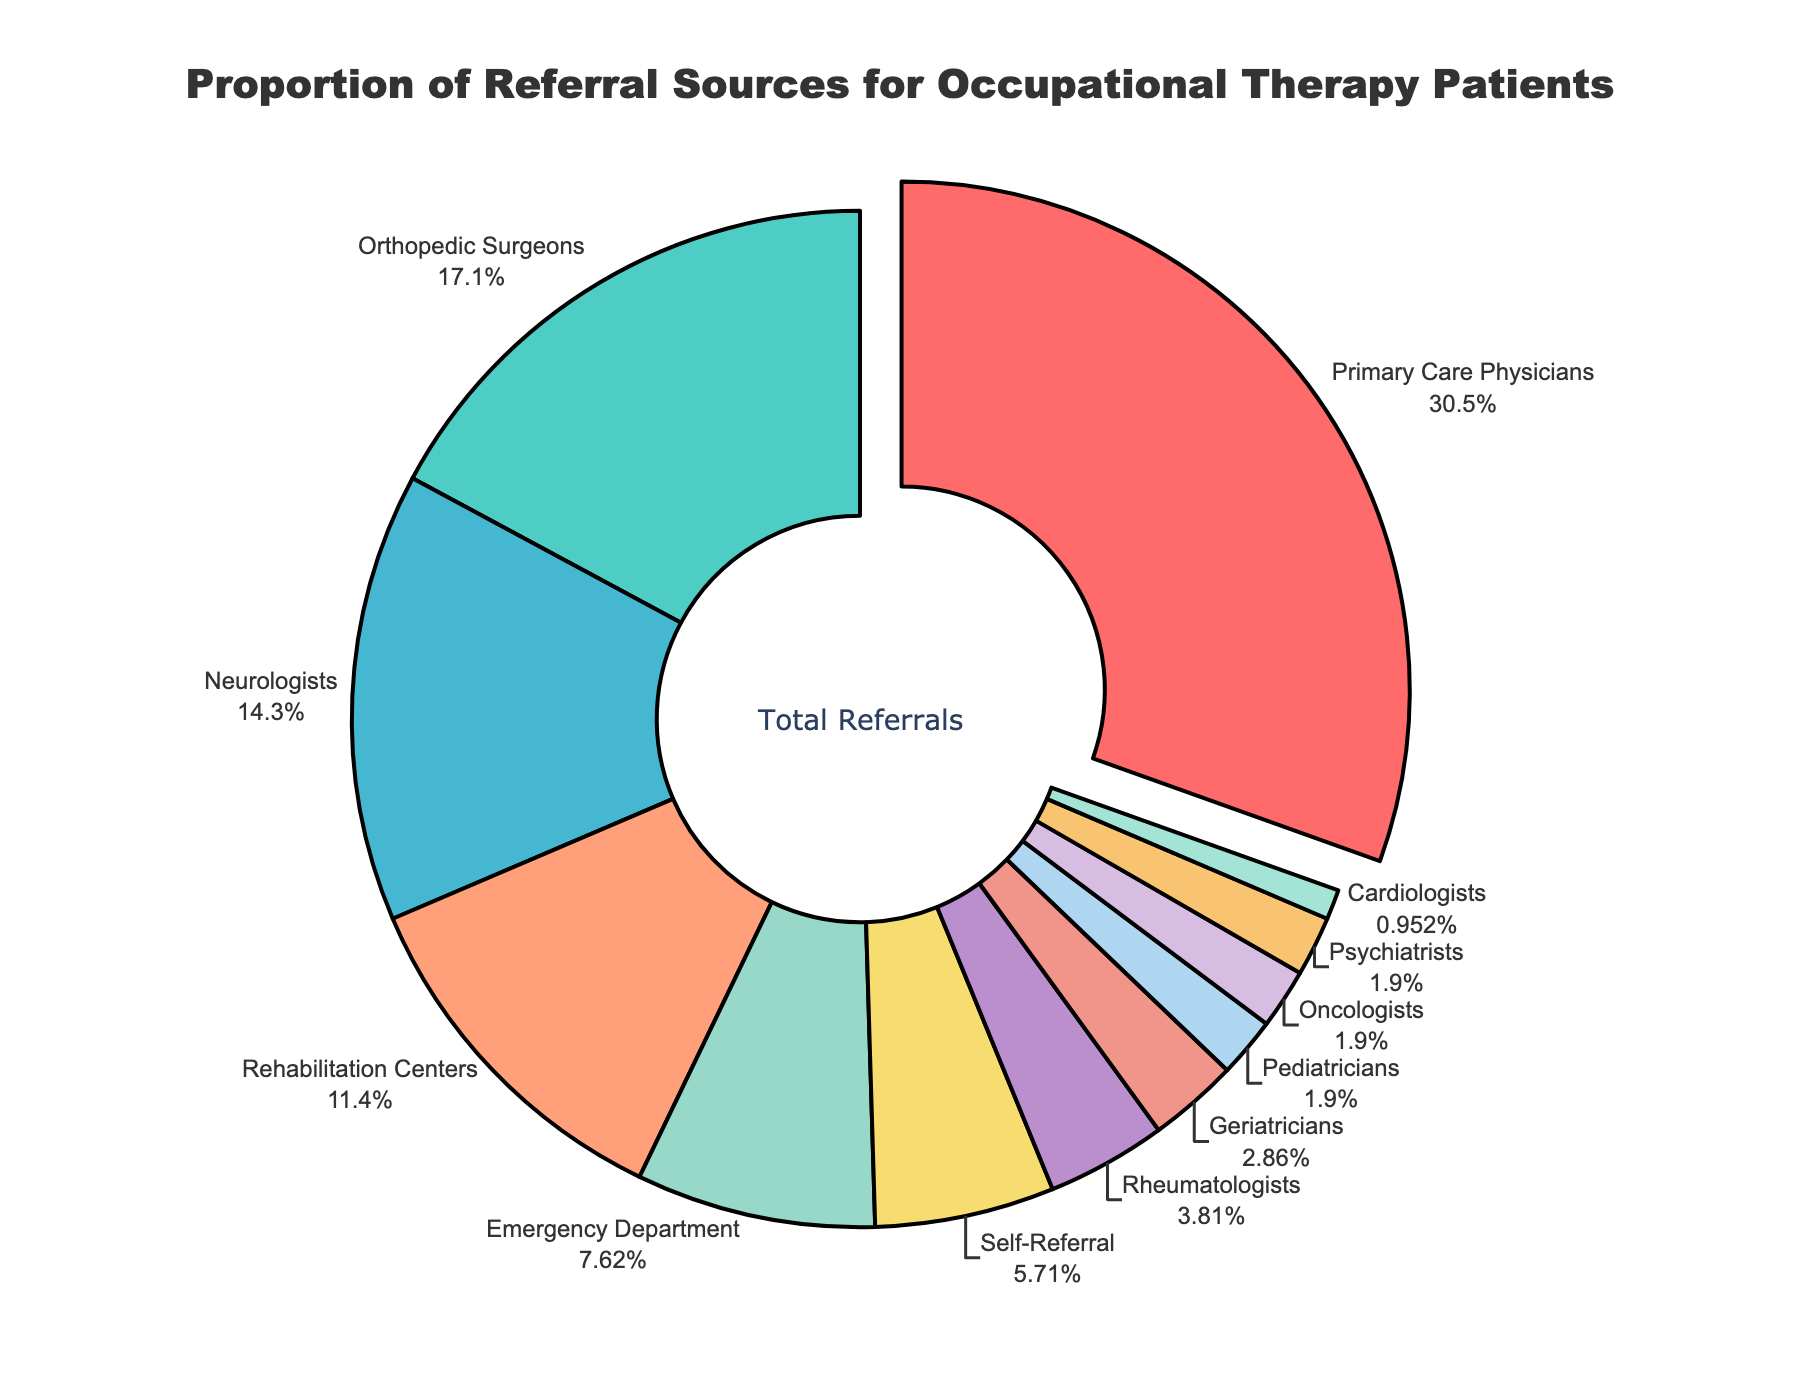What is the largest referral source for occupational therapy patients? The largest segment in the pie chart is highlighted by being slightly pulled out and has a label indicating 32%. This segment corresponds to Primary Care Physicians.
Answer: Primary Care Physicians Which referral source accounts for the smallest percentage of patients? The smallest segments in the pie chart, which are hardest to distinguish visually, each have a 1% label. This segment corresponds to Cardiologists.
Answer: Cardiologists How much greater is the proportion of referrals from Primary Care Physicians compared to Orthopedic Surgeons? The segment for Primary Care Physicians shows 32%, while Orthopedic Surgeons show 18%. The difference can be calculated as 32% - 18% = 14%.
Answer: 14% What percentage of referrals come from Neurologists and Pediatricians combined? The segment for Neurologists shows 15%, and for Pediatricians, it shows 2%. Adding these together: 15% + 2% = 17%.
Answer: 17% Which referral sources account for more patients combined: Emergency Departments and Self-Referral, or Rehabilitation Centers and Rheumatologists? Emergency Department has 8% and Self-Referral has 6%, summing to 14%. Rehabilitation Centers have 12% and Rheumatologists have 4%, summing to 16%. Comparing these, 14% for Emergency Departments and Self-Referral is less than 16% for Rehabilitation Centers and Rheumatologists.
Answer: Rehabilitation Centers and Rheumatologists Are there more referrals from Orthopedic Surgeons or from Neurologists and Emergency Departments combined? Orthopedic Surgeons account for 18%. Neurologists and Emergency Department combined are 15% + 8%, which is 23%. Thus, 18% (Orthopedic Surgeons) is less than 23% (Neurologists + Emergency Departments).
Answer: Neurologists and Emergency Departments What is the total percentage of referrals coming from specialties other than Primary Care Physicians, Orthopedic Surgeons, and Neurologists? The percentages of the named sources are 32%, 18%, and 15% respectively. Adding these: 32% + 18% + 15% = 65%. Subtracting from 100% gives the remaining percentage: 100% - 65% = 35%.
Answer: 35% Compare the combined percentage of referrals from Geriatricians, Pediatricians, Oncologists, Psychiatrists, and Cardiologists with the percentage from Rehabilitation Centers. Which group is higher? The combined percentage of the smaller groups is 3% (Geriatricians) + 2% (Pediatricians) + 2% (Oncologists) + 2% (Psychiatrists) + 1% (Cardiologists) = 10%. The percentage from Rehabilitation Centers is 12%. Therefore, 12% (Rehabilitation Centers) is higher than 10% (combined smaller groups).
Answer: Rehabilitation Centers Which two referral sources have the closest percentages? By observing the segments, Orthopedic Surgeons and Neurologists have very close percentages. Orthopedic Surgeons is 18% and Neurologists is 15%. The difference is 3%, which is the smallest difference between any two sources.
Answer: Orthopedic Surgeons and Neurologists 